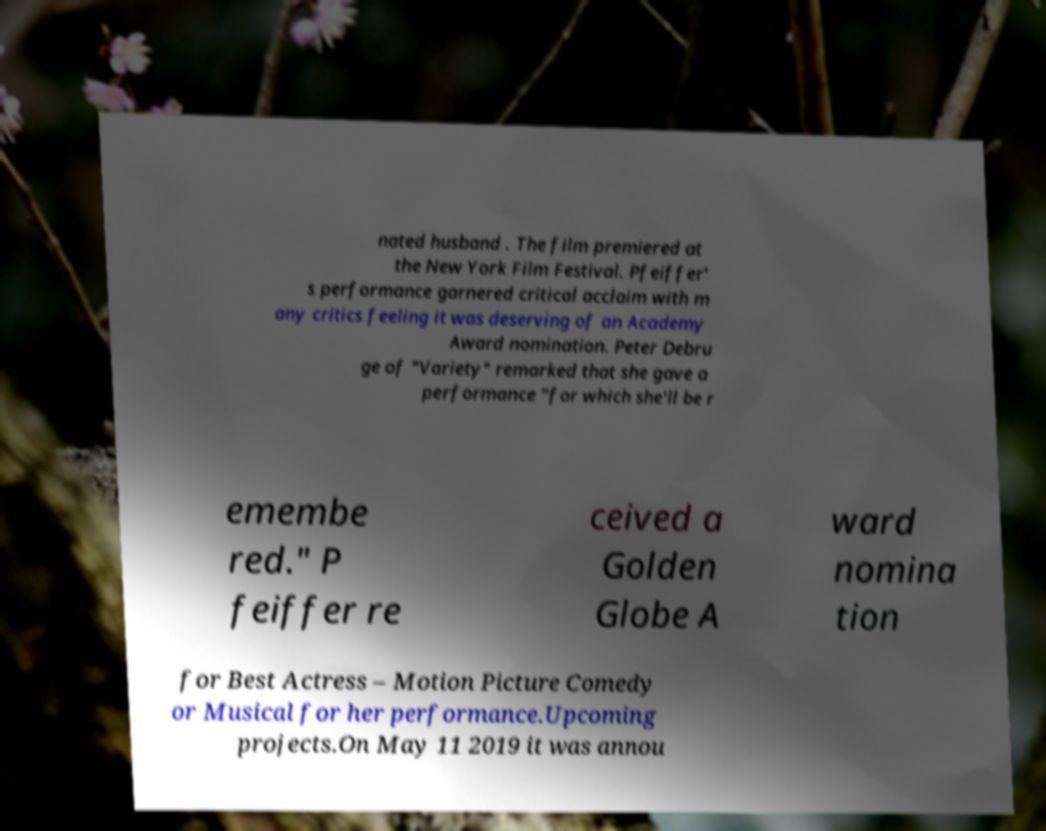Please identify and transcribe the text found in this image. nated husband . The film premiered at the New York Film Festival. Pfeiffer' s performance garnered critical acclaim with m any critics feeling it was deserving of an Academy Award nomination. Peter Debru ge of "Variety" remarked that she gave a performance "for which she'll be r emembe red." P feiffer re ceived a Golden Globe A ward nomina tion for Best Actress – Motion Picture Comedy or Musical for her performance.Upcoming projects.On May 11 2019 it was annou 